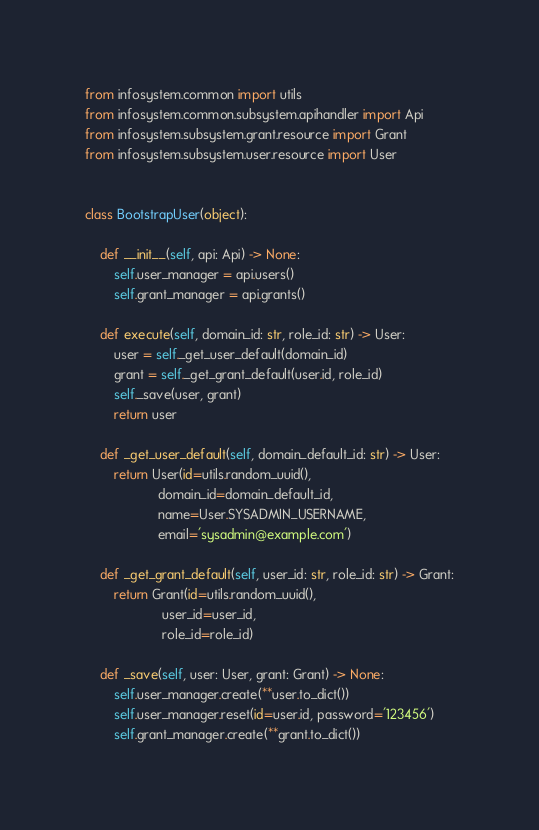<code> <loc_0><loc_0><loc_500><loc_500><_Python_>from infosystem.common import utils
from infosystem.common.subsystem.apihandler import Api
from infosystem.subsystem.grant.resource import Grant
from infosystem.subsystem.user.resource import User


class BootstrapUser(object):

    def __init__(self, api: Api) -> None:
        self.user_manager = api.users()
        self.grant_manager = api.grants()

    def execute(self, domain_id: str, role_id: str) -> User:
        user = self._get_user_default(domain_id)
        grant = self._get_grant_default(user.id, role_id)
        self._save(user, grant)
        return user

    def _get_user_default(self, domain_default_id: str) -> User:
        return User(id=utils.random_uuid(),
                    domain_id=domain_default_id,
                    name=User.SYSADMIN_USERNAME,
                    email='sysadmin@example.com')

    def _get_grant_default(self, user_id: str, role_id: str) -> Grant:
        return Grant(id=utils.random_uuid(),
                     user_id=user_id,
                     role_id=role_id)

    def _save(self, user: User, grant: Grant) -> None:
        self.user_manager.create(**user.to_dict())
        self.user_manager.reset(id=user.id, password='123456')
        self.grant_manager.create(**grant.to_dict())
</code> 